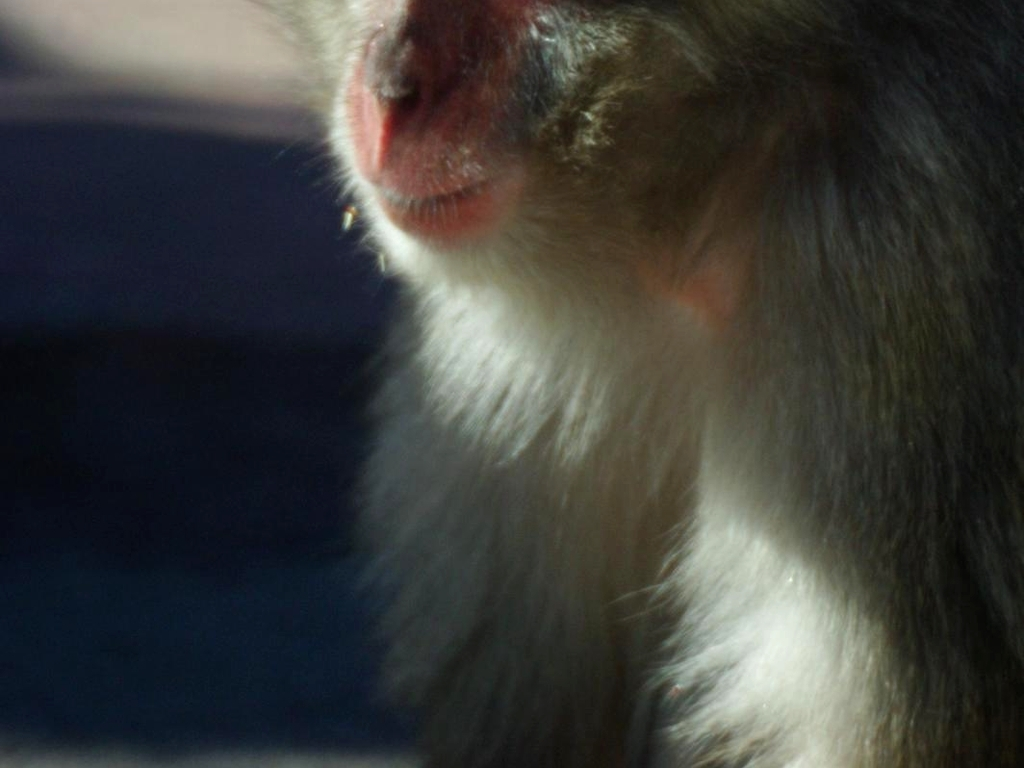Can you describe the overall mood conveyed by this image? The image has a contemplative and intimate feel, with the close-up of the subject and the soft lighting contributing to a peaceful and introspective atmosphere. 